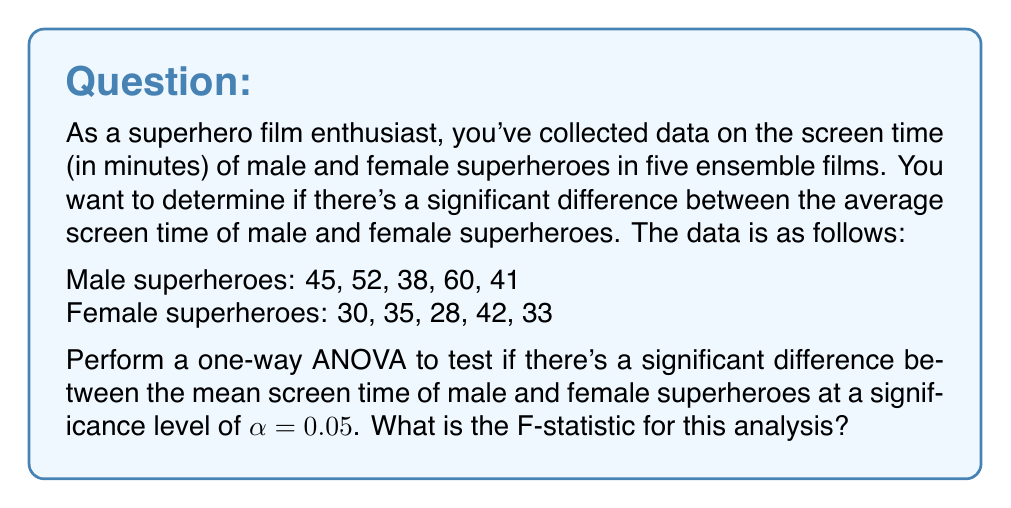What is the answer to this math problem? Let's approach this step-by-step using one-way ANOVA:

1) First, calculate the means for each group:
   Male mean ($\bar{X}_M$) = $(45 + 52 + 38 + 60 + 41) / 5 = 47.2$
   Female mean ($\bar{X}_F$) = $(30 + 35 + 28 + 42 + 33) / 5 = 33.6$

2) Calculate the grand mean:
   $\bar{X}_G = (47.2 + 33.6) / 2 = 40.4$

3) Calculate the Sum of Squares Between (SSB):
   $$SSB = n_M(\bar{X}_M - \bar{X}_G)^2 + n_F(\bar{X}_F - \bar{X}_G)^2$$
   $$SSB = 5(47.2 - 40.4)^2 + 5(33.6 - 40.4)^2 = 462.4 + 462.4 = 924.8$$

4) Calculate the Sum of Squares Within (SSW):
   $$SSW = \sum_{i=1}^{n_M} (X_{Mi} - \bar{X}_M)^2 + \sum_{i=1}^{n_F} (X_{Fi} - \bar{X}_F)^2$$
   $$SSW = [(45-47.2)^2 + (52-47.2)^2 + (38-47.2)^2 + (60-47.2)^2 + (41-47.2)^2] +$$
   $$[(30-33.6)^2 + (35-33.6)^2 + (28-33.6)^2 + (42-33.6)^2 + (33-33.6)^2]$$
   $$SSW = 308.8 + 158.8 = 467.6$$

5) Calculate the degrees of freedom:
   df(between) = number of groups - 1 = 2 - 1 = 1
   df(within) = total number of observations - number of groups = 10 - 2 = 8

6) Calculate Mean Square Between (MSB) and Mean Square Within (MSW):
   $$MSB = SSB / df(between) = 924.8 / 1 = 924.8$$
   $$MSW = SSW / df(within) = 467.6 / 8 = 58.45$$

7) Calculate the F-statistic:
   $$F = MSB / MSW = 924.8 / 58.45 = 15.82$$
Answer: The F-statistic for this analysis is 15.82. 